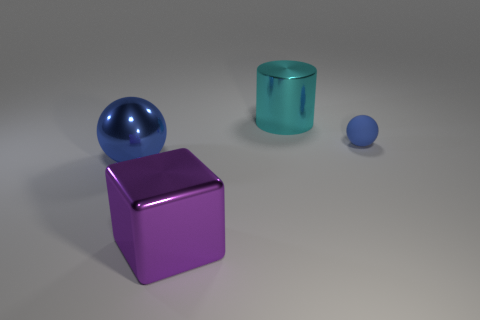Subtract 1 spheres. How many spheres are left? 1 Subtract all tiny brown spheres. Subtract all small things. How many objects are left? 3 Add 4 purple objects. How many purple objects are left? 5 Add 1 cubes. How many cubes exist? 2 Add 2 brown shiny spheres. How many objects exist? 6 Subtract 0 red blocks. How many objects are left? 4 Subtract all blocks. How many objects are left? 3 Subtract all yellow cylinders. Subtract all green blocks. How many cylinders are left? 1 Subtract all purple blocks. How many green cylinders are left? 0 